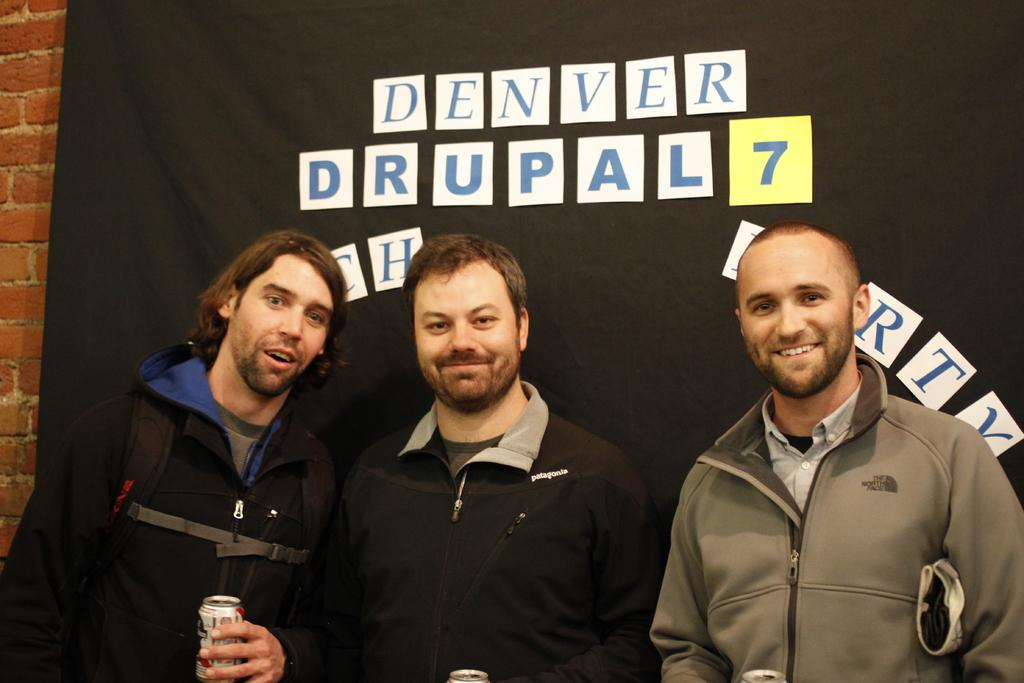<image>
Give a short and clear explanation of the subsequent image. Three men pose in front of a Denver Drupal 7 backdrop. 